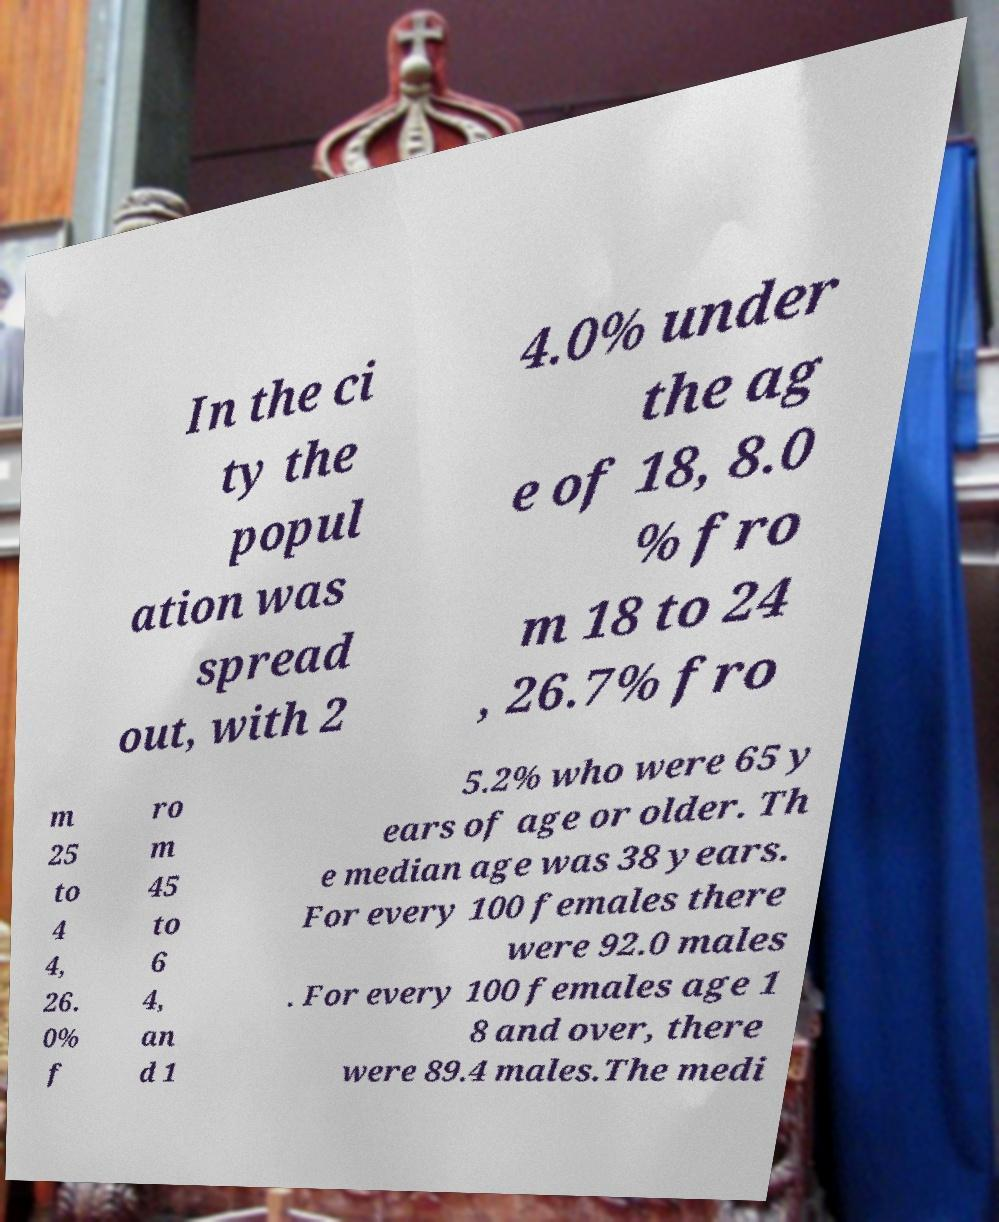Please identify and transcribe the text found in this image. In the ci ty the popul ation was spread out, with 2 4.0% under the ag e of 18, 8.0 % fro m 18 to 24 , 26.7% fro m 25 to 4 4, 26. 0% f ro m 45 to 6 4, an d 1 5.2% who were 65 y ears of age or older. Th e median age was 38 years. For every 100 females there were 92.0 males . For every 100 females age 1 8 and over, there were 89.4 males.The medi 